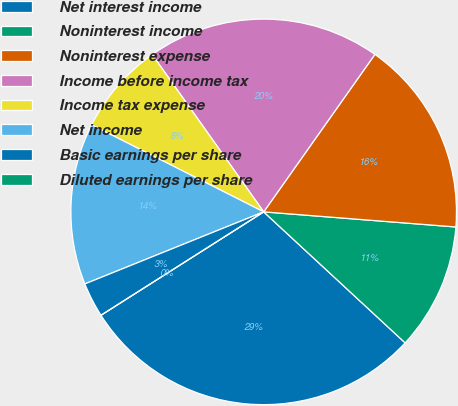Convert chart to OTSL. <chart><loc_0><loc_0><loc_500><loc_500><pie_chart><fcel>Net interest income<fcel>Noninterest income<fcel>Noninterest expense<fcel>Income before income tax<fcel>Income tax expense<fcel>Net income<fcel>Basic earnings per share<fcel>Diluted earnings per share<nl><fcel>29.1%<fcel>10.64%<fcel>16.46%<fcel>19.6%<fcel>7.73%<fcel>13.55%<fcel>2.91%<fcel>0.0%<nl></chart> 